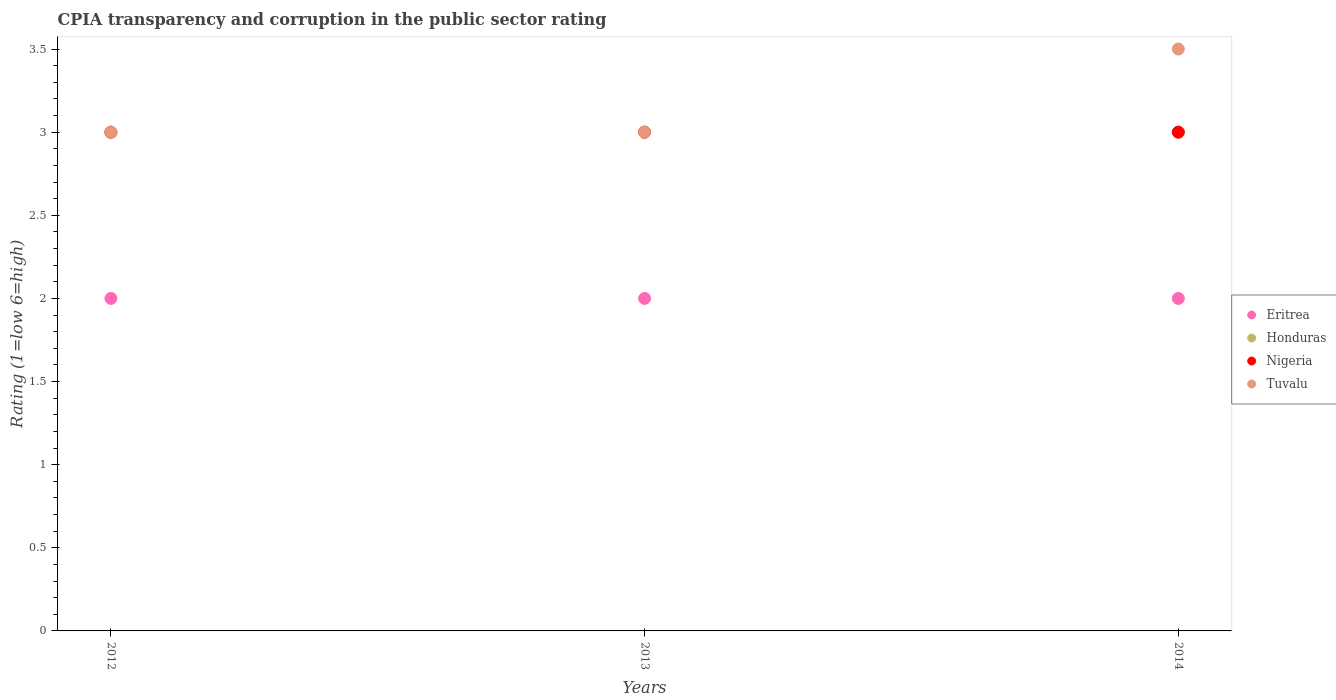Is the number of dotlines equal to the number of legend labels?
Your response must be concise. Yes. Across all years, what is the maximum CPIA rating in Nigeria?
Ensure brevity in your answer.  3. In which year was the CPIA rating in Tuvalu maximum?
Offer a very short reply. 2014. In which year was the CPIA rating in Eritrea minimum?
Your response must be concise. 2012. What is the average CPIA rating in Honduras per year?
Offer a very short reply. 3. What is the ratio of the CPIA rating in Eritrea in 2012 to that in 2013?
Your answer should be very brief. 1. Is the CPIA rating in Tuvalu in 2012 less than that in 2014?
Make the answer very short. Yes. Is the difference between the CPIA rating in Honduras in 2013 and 2014 greater than the difference between the CPIA rating in Nigeria in 2013 and 2014?
Offer a terse response. No. Is the sum of the CPIA rating in Nigeria in 2013 and 2014 greater than the maximum CPIA rating in Tuvalu across all years?
Your answer should be very brief. Yes. Is the CPIA rating in Nigeria strictly greater than the CPIA rating in Tuvalu over the years?
Give a very brief answer. No. Is the CPIA rating in Eritrea strictly less than the CPIA rating in Nigeria over the years?
Keep it short and to the point. Yes. How many dotlines are there?
Give a very brief answer. 4. How many years are there in the graph?
Provide a short and direct response. 3. What is the difference between two consecutive major ticks on the Y-axis?
Keep it short and to the point. 0.5. Are the values on the major ticks of Y-axis written in scientific E-notation?
Your answer should be very brief. No. Does the graph contain grids?
Your response must be concise. No. Where does the legend appear in the graph?
Make the answer very short. Center right. What is the title of the graph?
Your answer should be compact. CPIA transparency and corruption in the public sector rating. What is the label or title of the X-axis?
Keep it short and to the point. Years. What is the Rating (1=low 6=high) of Nigeria in 2012?
Your answer should be compact. 3. What is the Rating (1=low 6=high) of Eritrea in 2013?
Ensure brevity in your answer.  2. What is the Rating (1=low 6=high) of Honduras in 2013?
Keep it short and to the point. 3. What is the Rating (1=low 6=high) in Tuvalu in 2013?
Provide a succinct answer. 3. What is the Rating (1=low 6=high) of Eritrea in 2014?
Give a very brief answer. 2. What is the Rating (1=low 6=high) of Honduras in 2014?
Offer a terse response. 3. What is the Rating (1=low 6=high) in Nigeria in 2014?
Give a very brief answer. 3. What is the Rating (1=low 6=high) in Tuvalu in 2014?
Make the answer very short. 3.5. Across all years, what is the maximum Rating (1=low 6=high) in Eritrea?
Keep it short and to the point. 2. Across all years, what is the maximum Rating (1=low 6=high) in Honduras?
Give a very brief answer. 3. Across all years, what is the maximum Rating (1=low 6=high) of Nigeria?
Your answer should be compact. 3. Across all years, what is the maximum Rating (1=low 6=high) in Tuvalu?
Provide a short and direct response. 3.5. Across all years, what is the minimum Rating (1=low 6=high) of Eritrea?
Offer a very short reply. 2. Across all years, what is the minimum Rating (1=low 6=high) in Nigeria?
Your response must be concise. 3. What is the total Rating (1=low 6=high) in Honduras in the graph?
Your response must be concise. 9. What is the total Rating (1=low 6=high) in Nigeria in the graph?
Offer a very short reply. 9. What is the difference between the Rating (1=low 6=high) in Eritrea in 2012 and that in 2013?
Your answer should be very brief. 0. What is the difference between the Rating (1=low 6=high) in Nigeria in 2012 and that in 2013?
Offer a very short reply. 0. What is the difference between the Rating (1=low 6=high) of Tuvalu in 2012 and that in 2013?
Make the answer very short. 0. What is the difference between the Rating (1=low 6=high) of Honduras in 2012 and that in 2014?
Offer a very short reply. 0. What is the difference between the Rating (1=low 6=high) of Tuvalu in 2012 and that in 2014?
Offer a very short reply. -0.5. What is the difference between the Rating (1=low 6=high) in Honduras in 2013 and that in 2014?
Your answer should be compact. 0. What is the difference between the Rating (1=low 6=high) of Nigeria in 2012 and the Rating (1=low 6=high) of Tuvalu in 2013?
Give a very brief answer. 0. What is the difference between the Rating (1=low 6=high) of Eritrea in 2012 and the Rating (1=low 6=high) of Nigeria in 2014?
Give a very brief answer. -1. What is the difference between the Rating (1=low 6=high) of Eritrea in 2012 and the Rating (1=low 6=high) of Tuvalu in 2014?
Offer a terse response. -1.5. What is the difference between the Rating (1=low 6=high) in Honduras in 2012 and the Rating (1=low 6=high) in Nigeria in 2014?
Your answer should be very brief. 0. What is the difference between the Rating (1=low 6=high) of Honduras in 2012 and the Rating (1=low 6=high) of Tuvalu in 2014?
Your response must be concise. -0.5. What is the difference between the Rating (1=low 6=high) of Eritrea in 2013 and the Rating (1=low 6=high) of Honduras in 2014?
Give a very brief answer. -1. What is the difference between the Rating (1=low 6=high) of Eritrea in 2013 and the Rating (1=low 6=high) of Nigeria in 2014?
Your answer should be compact. -1. What is the difference between the Rating (1=low 6=high) in Eritrea in 2013 and the Rating (1=low 6=high) in Tuvalu in 2014?
Your answer should be compact. -1.5. What is the difference between the Rating (1=low 6=high) in Honduras in 2013 and the Rating (1=low 6=high) in Nigeria in 2014?
Keep it short and to the point. 0. What is the difference between the Rating (1=low 6=high) in Honduras in 2013 and the Rating (1=low 6=high) in Tuvalu in 2014?
Make the answer very short. -0.5. What is the difference between the Rating (1=low 6=high) in Nigeria in 2013 and the Rating (1=low 6=high) in Tuvalu in 2014?
Give a very brief answer. -0.5. What is the average Rating (1=low 6=high) in Eritrea per year?
Provide a short and direct response. 2. What is the average Rating (1=low 6=high) in Tuvalu per year?
Provide a succinct answer. 3.17. In the year 2012, what is the difference between the Rating (1=low 6=high) of Eritrea and Rating (1=low 6=high) of Nigeria?
Offer a terse response. -1. In the year 2012, what is the difference between the Rating (1=low 6=high) in Eritrea and Rating (1=low 6=high) in Tuvalu?
Your answer should be very brief. -1. In the year 2012, what is the difference between the Rating (1=low 6=high) in Honduras and Rating (1=low 6=high) in Tuvalu?
Make the answer very short. 0. In the year 2013, what is the difference between the Rating (1=low 6=high) of Eritrea and Rating (1=low 6=high) of Honduras?
Make the answer very short. -1. In the year 2013, what is the difference between the Rating (1=low 6=high) of Nigeria and Rating (1=low 6=high) of Tuvalu?
Keep it short and to the point. 0. In the year 2014, what is the difference between the Rating (1=low 6=high) of Honduras and Rating (1=low 6=high) of Nigeria?
Provide a succinct answer. 0. In the year 2014, what is the difference between the Rating (1=low 6=high) of Honduras and Rating (1=low 6=high) of Tuvalu?
Provide a succinct answer. -0.5. What is the ratio of the Rating (1=low 6=high) of Nigeria in 2012 to that in 2013?
Offer a very short reply. 1. What is the ratio of the Rating (1=low 6=high) of Tuvalu in 2012 to that in 2013?
Give a very brief answer. 1. What is the ratio of the Rating (1=low 6=high) of Eritrea in 2012 to that in 2014?
Provide a succinct answer. 1. What is the ratio of the Rating (1=low 6=high) in Honduras in 2012 to that in 2014?
Offer a terse response. 1. What is the ratio of the Rating (1=low 6=high) in Nigeria in 2012 to that in 2014?
Your answer should be very brief. 1. What is the ratio of the Rating (1=low 6=high) of Nigeria in 2013 to that in 2014?
Offer a terse response. 1. What is the difference between the highest and the second highest Rating (1=low 6=high) of Tuvalu?
Ensure brevity in your answer.  0.5. What is the difference between the highest and the lowest Rating (1=low 6=high) of Eritrea?
Offer a terse response. 0. What is the difference between the highest and the lowest Rating (1=low 6=high) in Nigeria?
Offer a very short reply. 0. What is the difference between the highest and the lowest Rating (1=low 6=high) in Tuvalu?
Your answer should be compact. 0.5. 